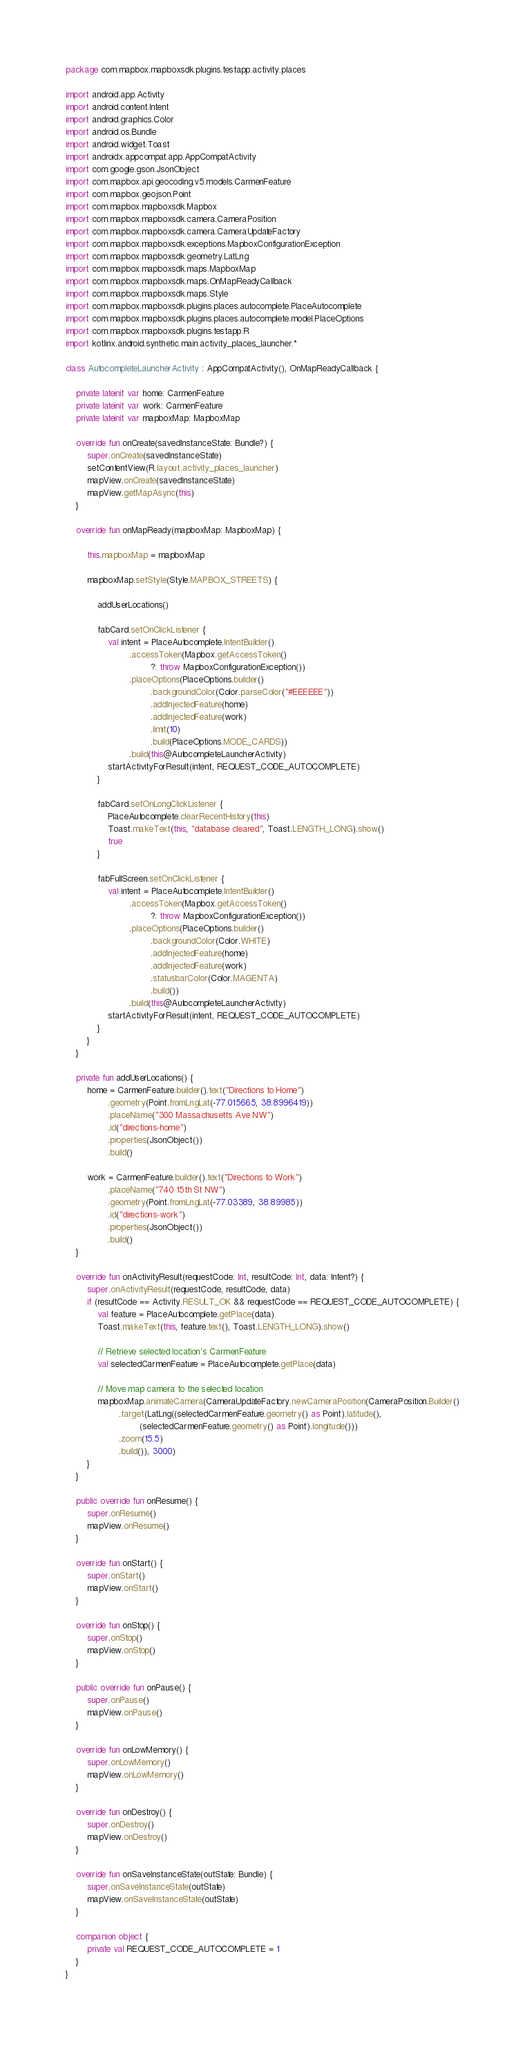<code> <loc_0><loc_0><loc_500><loc_500><_Kotlin_>package com.mapbox.mapboxsdk.plugins.testapp.activity.places

import android.app.Activity
import android.content.Intent
import android.graphics.Color
import android.os.Bundle
import android.widget.Toast
import androidx.appcompat.app.AppCompatActivity
import com.google.gson.JsonObject
import com.mapbox.api.geocoding.v5.models.CarmenFeature
import com.mapbox.geojson.Point
import com.mapbox.mapboxsdk.Mapbox
import com.mapbox.mapboxsdk.camera.CameraPosition
import com.mapbox.mapboxsdk.camera.CameraUpdateFactory
import com.mapbox.mapboxsdk.exceptions.MapboxConfigurationException
import com.mapbox.mapboxsdk.geometry.LatLng
import com.mapbox.mapboxsdk.maps.MapboxMap
import com.mapbox.mapboxsdk.maps.OnMapReadyCallback
import com.mapbox.mapboxsdk.maps.Style
import com.mapbox.mapboxsdk.plugins.places.autocomplete.PlaceAutocomplete
import com.mapbox.mapboxsdk.plugins.places.autocomplete.model.PlaceOptions
import com.mapbox.mapboxsdk.plugins.testapp.R
import kotlinx.android.synthetic.main.activity_places_launcher.*

class AutocompleteLauncherActivity : AppCompatActivity(), OnMapReadyCallback {

    private lateinit var home: CarmenFeature
    private lateinit var work: CarmenFeature
    private lateinit var mapboxMap: MapboxMap

    override fun onCreate(savedInstanceState: Bundle?) {
        super.onCreate(savedInstanceState)
        setContentView(R.layout.activity_places_launcher)
        mapView.onCreate(savedInstanceState)
        mapView.getMapAsync(this)
    }

    override fun onMapReady(mapboxMap: MapboxMap) {

        this.mapboxMap = mapboxMap

        mapboxMap.setStyle(Style.MAPBOX_STREETS) {

            addUserLocations()

            fabCard.setOnClickListener {
                val intent = PlaceAutocomplete.IntentBuilder()
                        .accessToken(Mapbox.getAccessToken()
                                ?: throw MapboxConfigurationException())
                        .placeOptions(PlaceOptions.builder()
                                .backgroundColor(Color.parseColor("#EEEEEE"))
                                .addInjectedFeature(home)
                                .addInjectedFeature(work)
                                .limit(10)
                                .build(PlaceOptions.MODE_CARDS))
                        .build(this@AutocompleteLauncherActivity)
                startActivityForResult(intent, REQUEST_CODE_AUTOCOMPLETE)
            }

            fabCard.setOnLongClickListener {
                PlaceAutocomplete.clearRecentHistory(this)
                Toast.makeText(this, "database cleared", Toast.LENGTH_LONG).show()
                true
            }

            fabFullScreen.setOnClickListener {
                val intent = PlaceAutocomplete.IntentBuilder()
                        .accessToken(Mapbox.getAccessToken()
                                ?: throw MapboxConfigurationException())
                        .placeOptions(PlaceOptions.builder()
                                .backgroundColor(Color.WHITE)
                                .addInjectedFeature(home)
                                .addInjectedFeature(work)
                                .statusbarColor(Color.MAGENTA)
                                .build())
                        .build(this@AutocompleteLauncherActivity)
                startActivityForResult(intent, REQUEST_CODE_AUTOCOMPLETE)
            }
        }
    }

    private fun addUserLocations() {
        home = CarmenFeature.builder().text("Directions to Home")
                .geometry(Point.fromLngLat(-77.015665, 38.8996419))
                .placeName("300 Massachusetts Ave NW")
                .id("directions-home")
                .properties(JsonObject())
                .build()

        work = CarmenFeature.builder().text("Directions to Work")
                .placeName("740 15th St NW")
                .geometry(Point.fromLngLat(-77.03389, 38.89985))
                .id("directions-work")
                .properties(JsonObject())
                .build()
    }

    override fun onActivityResult(requestCode: Int, resultCode: Int, data: Intent?) {
        super.onActivityResult(requestCode, resultCode, data)
        if (resultCode == Activity.RESULT_OK && requestCode == REQUEST_CODE_AUTOCOMPLETE) {
            val feature = PlaceAutocomplete.getPlace(data)
            Toast.makeText(this, feature.text(), Toast.LENGTH_LONG).show()

            // Retrieve selected location's CarmenFeature
            val selectedCarmenFeature = PlaceAutocomplete.getPlace(data)

            // Move map camera to the selected location
            mapboxMap.animateCamera(CameraUpdateFactory.newCameraPosition(CameraPosition.Builder()
                    .target(LatLng((selectedCarmenFeature.geometry() as Point).latitude(),
                            (selectedCarmenFeature.geometry() as Point).longitude()))
                    .zoom(15.5)
                    .build()), 3000)
        }
    }

    public override fun onResume() {
        super.onResume()
        mapView.onResume()
    }

    override fun onStart() {
        super.onStart()
        mapView.onStart()
    }

    override fun onStop() {
        super.onStop()
        mapView.onStop()
    }

    public override fun onPause() {
        super.onPause()
        mapView.onPause()
    }

    override fun onLowMemory() {
        super.onLowMemory()
        mapView.onLowMemory()
    }

    override fun onDestroy() {
        super.onDestroy()
        mapView.onDestroy()
    }

    override fun onSaveInstanceState(outState: Bundle) {
        super.onSaveInstanceState(outState)
        mapView.onSaveInstanceState(outState)
    }

    companion object {
        private val REQUEST_CODE_AUTOCOMPLETE = 1
    }
}
</code> 